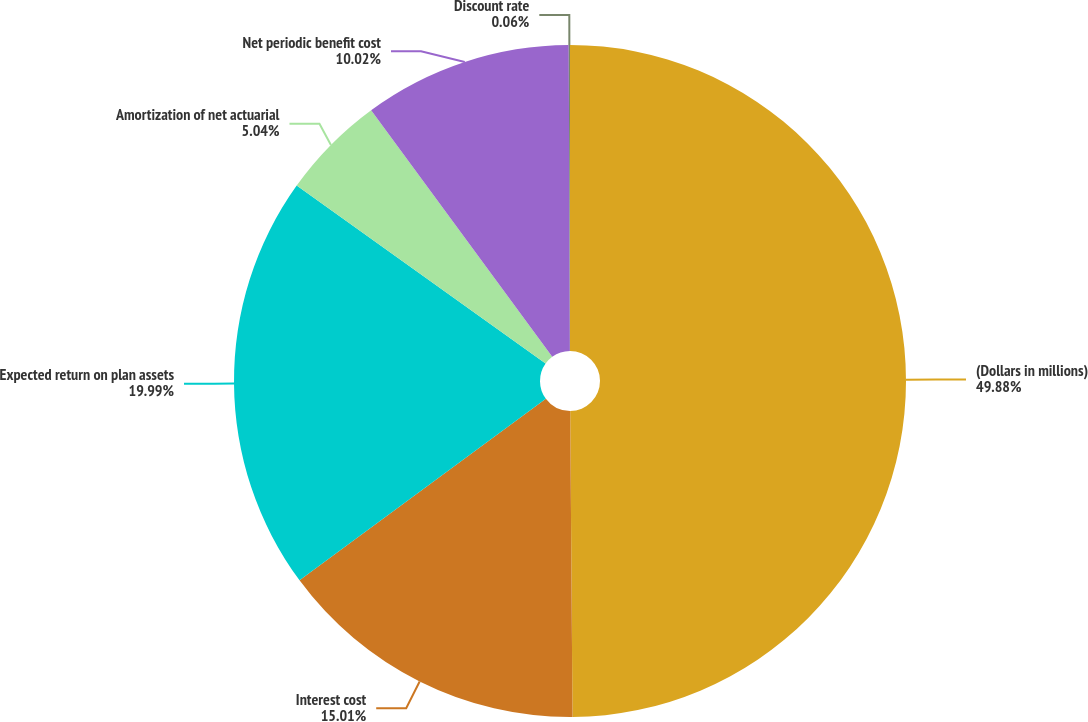<chart> <loc_0><loc_0><loc_500><loc_500><pie_chart><fcel>(Dollars in millions)<fcel>Interest cost<fcel>Expected return on plan assets<fcel>Amortization of net actuarial<fcel>Net periodic benefit cost<fcel>Discount rate<nl><fcel>49.88%<fcel>15.01%<fcel>19.99%<fcel>5.04%<fcel>10.02%<fcel>0.06%<nl></chart> 